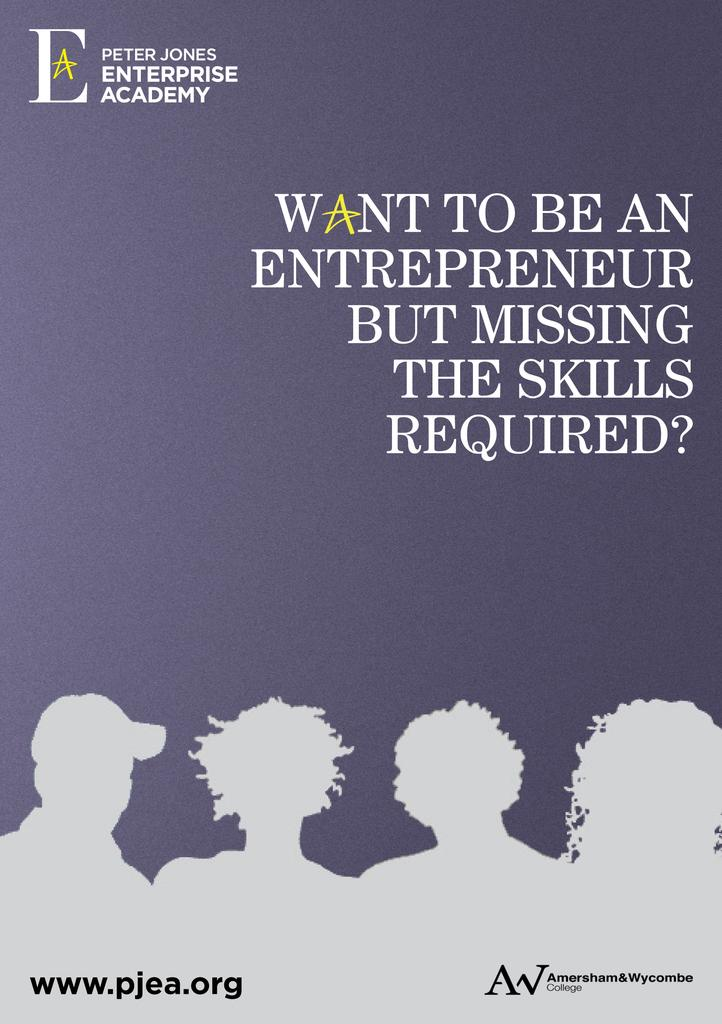<image>
Share a concise interpretation of the image provided. a book that talks about becoming an entrepreneur and what skills are needd 